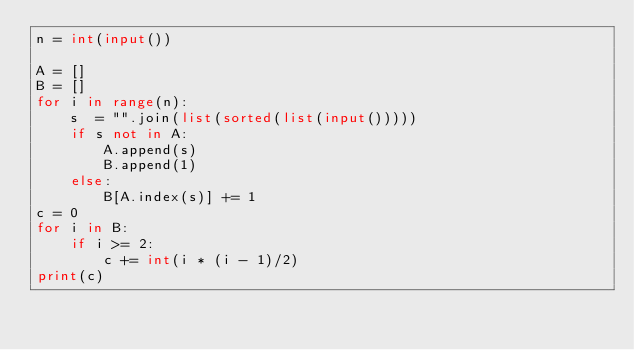<code> <loc_0><loc_0><loc_500><loc_500><_Python_>n = int(input())

A = []
B = []
for i in range(n):
    s  = "".join(list(sorted(list(input())))) 
    if s not in A:
        A.append(s)
        B.append(1)
    else:
        B[A.index(s)] += 1
c = 0
for i in B:
    if i >= 2:
        c += int(i * (i - 1)/2)
print(c)</code> 